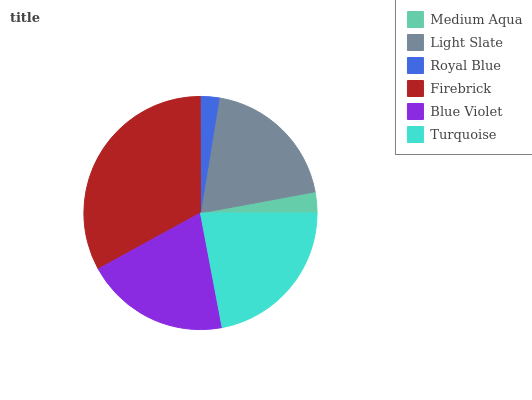Is Royal Blue the minimum?
Answer yes or no. Yes. Is Firebrick the maximum?
Answer yes or no. Yes. Is Light Slate the minimum?
Answer yes or no. No. Is Light Slate the maximum?
Answer yes or no. No. Is Light Slate greater than Medium Aqua?
Answer yes or no. Yes. Is Medium Aqua less than Light Slate?
Answer yes or no. Yes. Is Medium Aqua greater than Light Slate?
Answer yes or no. No. Is Light Slate less than Medium Aqua?
Answer yes or no. No. Is Blue Violet the high median?
Answer yes or no. Yes. Is Light Slate the low median?
Answer yes or no. Yes. Is Turquoise the high median?
Answer yes or no. No. Is Turquoise the low median?
Answer yes or no. No. 